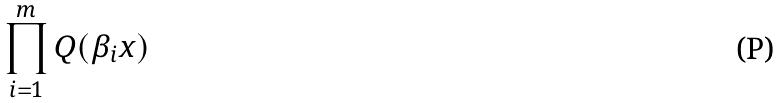Convert formula to latex. <formula><loc_0><loc_0><loc_500><loc_500>\prod _ { i = 1 } ^ { m } Q ( \beta _ { i } x )</formula> 